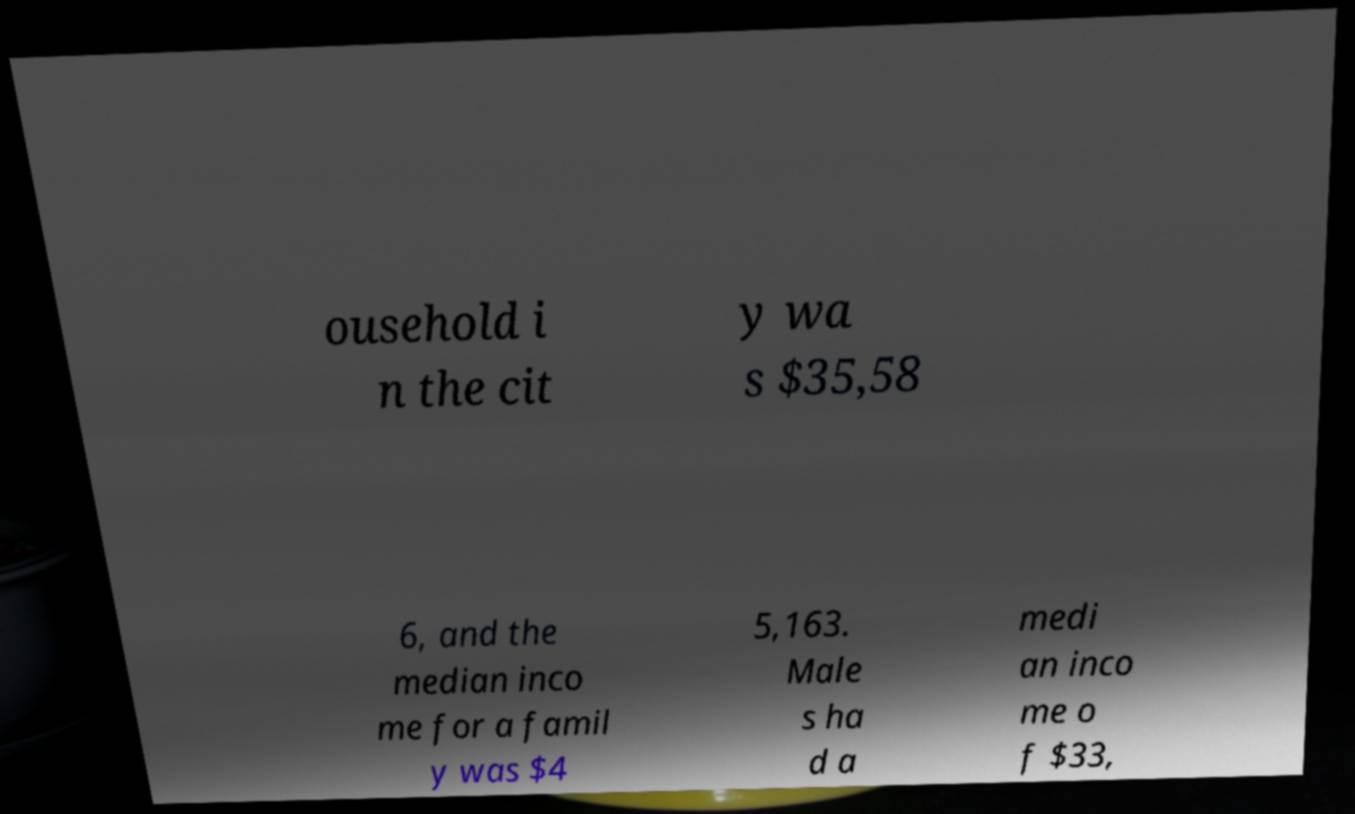For documentation purposes, I need the text within this image transcribed. Could you provide that? ousehold i n the cit y wa s $35,58 6, and the median inco me for a famil y was $4 5,163. Male s ha d a medi an inco me o f $33, 